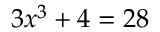<formula> <loc_0><loc_0><loc_500><loc_500>3 x ^ { 3 } + 4 = 2 8</formula> 